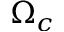Convert formula to latex. <formula><loc_0><loc_0><loc_500><loc_500>\Omega _ { c }</formula> 